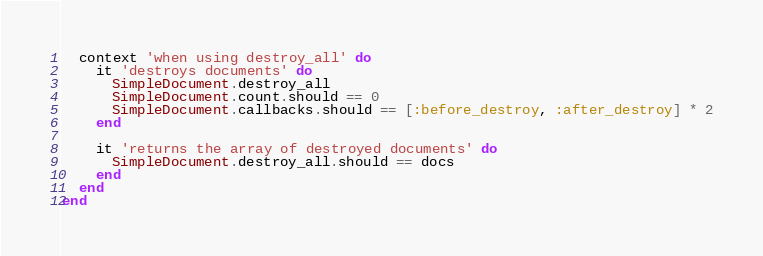<code> <loc_0><loc_0><loc_500><loc_500><_Ruby_>  context 'when using destroy_all' do
    it 'destroys documents' do
      SimpleDocument.destroy_all
      SimpleDocument.count.should == 0
      SimpleDocument.callbacks.should == [:before_destroy, :after_destroy] * 2
    end

    it 'returns the array of destroyed documents' do
      SimpleDocument.destroy_all.should == docs
    end
  end
end
</code> 